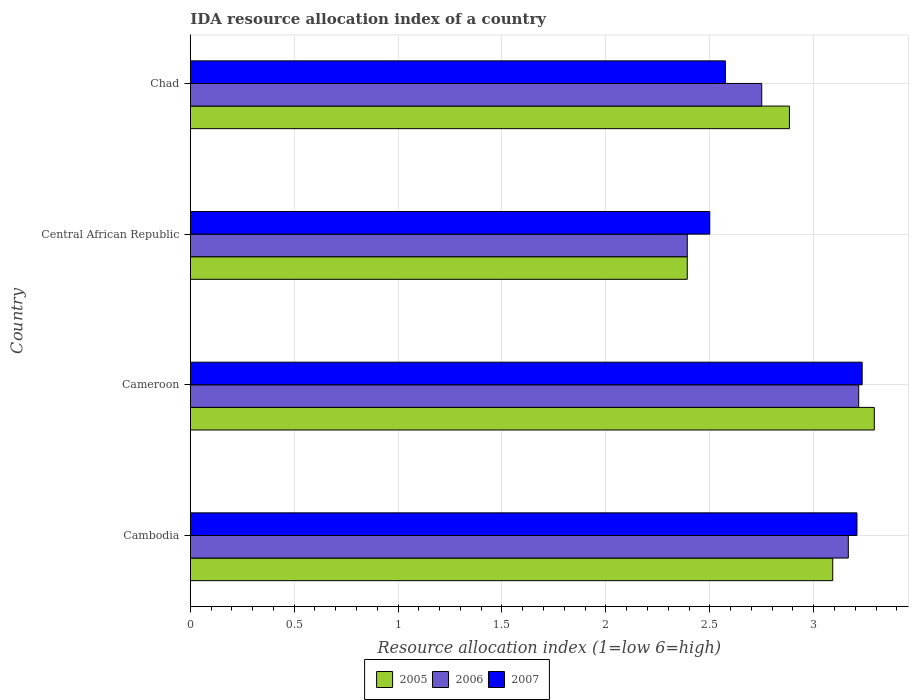How many groups of bars are there?
Provide a short and direct response. 4. Are the number of bars on each tick of the Y-axis equal?
Keep it short and to the point. Yes. How many bars are there on the 2nd tick from the bottom?
Ensure brevity in your answer.  3. What is the label of the 2nd group of bars from the top?
Provide a succinct answer. Central African Republic. What is the IDA resource allocation index in 2005 in Cameroon?
Ensure brevity in your answer.  3.29. Across all countries, what is the maximum IDA resource allocation index in 2006?
Keep it short and to the point. 3.22. Across all countries, what is the minimum IDA resource allocation index in 2005?
Make the answer very short. 2.39. In which country was the IDA resource allocation index in 2007 maximum?
Give a very brief answer. Cameroon. In which country was the IDA resource allocation index in 2005 minimum?
Provide a short and direct response. Central African Republic. What is the total IDA resource allocation index in 2006 in the graph?
Your response must be concise. 11.53. What is the difference between the IDA resource allocation index in 2006 in Cameroon and that in Chad?
Make the answer very short. 0.47. What is the difference between the IDA resource allocation index in 2007 in Cambodia and the IDA resource allocation index in 2006 in Chad?
Your answer should be compact. 0.46. What is the average IDA resource allocation index in 2006 per country?
Your answer should be compact. 2.88. What is the difference between the IDA resource allocation index in 2007 and IDA resource allocation index in 2006 in Central African Republic?
Ensure brevity in your answer.  0.11. What is the ratio of the IDA resource allocation index in 2005 in Cambodia to that in Central African Republic?
Your answer should be compact. 1.29. What is the difference between the highest and the second highest IDA resource allocation index in 2007?
Your answer should be very brief. 0.02. What is the difference between the highest and the lowest IDA resource allocation index in 2005?
Make the answer very short. 0.9. Is the sum of the IDA resource allocation index in 2006 in Cambodia and Cameroon greater than the maximum IDA resource allocation index in 2007 across all countries?
Ensure brevity in your answer.  Yes. Is it the case that in every country, the sum of the IDA resource allocation index in 2007 and IDA resource allocation index in 2006 is greater than the IDA resource allocation index in 2005?
Give a very brief answer. Yes. How many bars are there?
Give a very brief answer. 12. Are all the bars in the graph horizontal?
Your answer should be compact. Yes. Does the graph contain any zero values?
Provide a succinct answer. No. What is the title of the graph?
Provide a succinct answer. IDA resource allocation index of a country. What is the label or title of the X-axis?
Keep it short and to the point. Resource allocation index (1=low 6=high). What is the label or title of the Y-axis?
Your response must be concise. Country. What is the Resource allocation index (1=low 6=high) of 2005 in Cambodia?
Ensure brevity in your answer.  3.09. What is the Resource allocation index (1=low 6=high) in 2006 in Cambodia?
Offer a terse response. 3.17. What is the Resource allocation index (1=low 6=high) in 2007 in Cambodia?
Provide a short and direct response. 3.21. What is the Resource allocation index (1=low 6=high) in 2005 in Cameroon?
Give a very brief answer. 3.29. What is the Resource allocation index (1=low 6=high) in 2006 in Cameroon?
Provide a succinct answer. 3.22. What is the Resource allocation index (1=low 6=high) of 2007 in Cameroon?
Make the answer very short. 3.23. What is the Resource allocation index (1=low 6=high) in 2005 in Central African Republic?
Offer a terse response. 2.39. What is the Resource allocation index (1=low 6=high) in 2006 in Central African Republic?
Give a very brief answer. 2.39. What is the Resource allocation index (1=low 6=high) of 2005 in Chad?
Provide a short and direct response. 2.88. What is the Resource allocation index (1=low 6=high) of 2006 in Chad?
Offer a terse response. 2.75. What is the Resource allocation index (1=low 6=high) in 2007 in Chad?
Provide a short and direct response. 2.58. Across all countries, what is the maximum Resource allocation index (1=low 6=high) in 2005?
Provide a short and direct response. 3.29. Across all countries, what is the maximum Resource allocation index (1=low 6=high) of 2006?
Offer a very short reply. 3.22. Across all countries, what is the maximum Resource allocation index (1=low 6=high) of 2007?
Provide a short and direct response. 3.23. Across all countries, what is the minimum Resource allocation index (1=low 6=high) in 2005?
Provide a succinct answer. 2.39. Across all countries, what is the minimum Resource allocation index (1=low 6=high) in 2006?
Make the answer very short. 2.39. What is the total Resource allocation index (1=low 6=high) of 2005 in the graph?
Give a very brief answer. 11.66. What is the total Resource allocation index (1=low 6=high) of 2006 in the graph?
Offer a very short reply. 11.53. What is the total Resource allocation index (1=low 6=high) in 2007 in the graph?
Keep it short and to the point. 11.52. What is the difference between the Resource allocation index (1=low 6=high) of 2007 in Cambodia and that in Cameroon?
Make the answer very short. -0.03. What is the difference between the Resource allocation index (1=low 6=high) in 2005 in Cambodia and that in Central African Republic?
Offer a terse response. 0.7. What is the difference between the Resource allocation index (1=low 6=high) in 2006 in Cambodia and that in Central African Republic?
Provide a succinct answer. 0.78. What is the difference between the Resource allocation index (1=low 6=high) in 2007 in Cambodia and that in Central African Republic?
Keep it short and to the point. 0.71. What is the difference between the Resource allocation index (1=low 6=high) of 2005 in Cambodia and that in Chad?
Your response must be concise. 0.21. What is the difference between the Resource allocation index (1=low 6=high) in 2006 in Cambodia and that in Chad?
Keep it short and to the point. 0.42. What is the difference between the Resource allocation index (1=low 6=high) in 2007 in Cambodia and that in Chad?
Offer a terse response. 0.63. What is the difference between the Resource allocation index (1=low 6=high) of 2006 in Cameroon and that in Central African Republic?
Keep it short and to the point. 0.82. What is the difference between the Resource allocation index (1=low 6=high) in 2007 in Cameroon and that in Central African Republic?
Keep it short and to the point. 0.73. What is the difference between the Resource allocation index (1=low 6=high) of 2005 in Cameroon and that in Chad?
Give a very brief answer. 0.41. What is the difference between the Resource allocation index (1=low 6=high) of 2006 in Cameroon and that in Chad?
Your answer should be very brief. 0.47. What is the difference between the Resource allocation index (1=low 6=high) of 2007 in Cameroon and that in Chad?
Ensure brevity in your answer.  0.66. What is the difference between the Resource allocation index (1=low 6=high) in 2005 in Central African Republic and that in Chad?
Ensure brevity in your answer.  -0.49. What is the difference between the Resource allocation index (1=low 6=high) in 2006 in Central African Republic and that in Chad?
Ensure brevity in your answer.  -0.36. What is the difference between the Resource allocation index (1=low 6=high) of 2007 in Central African Republic and that in Chad?
Provide a short and direct response. -0.07. What is the difference between the Resource allocation index (1=low 6=high) in 2005 in Cambodia and the Resource allocation index (1=low 6=high) in 2006 in Cameroon?
Offer a terse response. -0.12. What is the difference between the Resource allocation index (1=low 6=high) in 2005 in Cambodia and the Resource allocation index (1=low 6=high) in 2007 in Cameroon?
Your answer should be very brief. -0.14. What is the difference between the Resource allocation index (1=low 6=high) in 2006 in Cambodia and the Resource allocation index (1=low 6=high) in 2007 in Cameroon?
Your response must be concise. -0.07. What is the difference between the Resource allocation index (1=low 6=high) of 2005 in Cambodia and the Resource allocation index (1=low 6=high) of 2007 in Central African Republic?
Your answer should be compact. 0.59. What is the difference between the Resource allocation index (1=low 6=high) of 2005 in Cambodia and the Resource allocation index (1=low 6=high) of 2006 in Chad?
Provide a short and direct response. 0.34. What is the difference between the Resource allocation index (1=low 6=high) in 2005 in Cambodia and the Resource allocation index (1=low 6=high) in 2007 in Chad?
Your response must be concise. 0.52. What is the difference between the Resource allocation index (1=low 6=high) of 2006 in Cambodia and the Resource allocation index (1=low 6=high) of 2007 in Chad?
Ensure brevity in your answer.  0.59. What is the difference between the Resource allocation index (1=low 6=high) of 2005 in Cameroon and the Resource allocation index (1=low 6=high) of 2006 in Central African Republic?
Provide a short and direct response. 0.9. What is the difference between the Resource allocation index (1=low 6=high) of 2005 in Cameroon and the Resource allocation index (1=low 6=high) of 2007 in Central African Republic?
Offer a very short reply. 0.79. What is the difference between the Resource allocation index (1=low 6=high) in 2006 in Cameroon and the Resource allocation index (1=low 6=high) in 2007 in Central African Republic?
Provide a succinct answer. 0.72. What is the difference between the Resource allocation index (1=low 6=high) in 2005 in Cameroon and the Resource allocation index (1=low 6=high) in 2006 in Chad?
Offer a very short reply. 0.54. What is the difference between the Resource allocation index (1=low 6=high) in 2005 in Cameroon and the Resource allocation index (1=low 6=high) in 2007 in Chad?
Provide a succinct answer. 0.72. What is the difference between the Resource allocation index (1=low 6=high) in 2006 in Cameroon and the Resource allocation index (1=low 6=high) in 2007 in Chad?
Offer a terse response. 0.64. What is the difference between the Resource allocation index (1=low 6=high) of 2005 in Central African Republic and the Resource allocation index (1=low 6=high) of 2006 in Chad?
Your answer should be compact. -0.36. What is the difference between the Resource allocation index (1=low 6=high) of 2005 in Central African Republic and the Resource allocation index (1=low 6=high) of 2007 in Chad?
Offer a terse response. -0.18. What is the difference between the Resource allocation index (1=low 6=high) in 2006 in Central African Republic and the Resource allocation index (1=low 6=high) in 2007 in Chad?
Keep it short and to the point. -0.18. What is the average Resource allocation index (1=low 6=high) in 2005 per country?
Provide a short and direct response. 2.91. What is the average Resource allocation index (1=low 6=high) of 2006 per country?
Provide a short and direct response. 2.88. What is the average Resource allocation index (1=low 6=high) of 2007 per country?
Your answer should be very brief. 2.88. What is the difference between the Resource allocation index (1=low 6=high) of 2005 and Resource allocation index (1=low 6=high) of 2006 in Cambodia?
Give a very brief answer. -0.07. What is the difference between the Resource allocation index (1=low 6=high) of 2005 and Resource allocation index (1=low 6=high) of 2007 in Cambodia?
Ensure brevity in your answer.  -0.12. What is the difference between the Resource allocation index (1=low 6=high) in 2006 and Resource allocation index (1=low 6=high) in 2007 in Cambodia?
Give a very brief answer. -0.04. What is the difference between the Resource allocation index (1=low 6=high) in 2005 and Resource allocation index (1=low 6=high) in 2006 in Cameroon?
Keep it short and to the point. 0.07. What is the difference between the Resource allocation index (1=low 6=high) in 2005 and Resource allocation index (1=low 6=high) in 2007 in Cameroon?
Your answer should be compact. 0.06. What is the difference between the Resource allocation index (1=low 6=high) of 2006 and Resource allocation index (1=low 6=high) of 2007 in Cameroon?
Your answer should be compact. -0.02. What is the difference between the Resource allocation index (1=low 6=high) in 2005 and Resource allocation index (1=low 6=high) in 2006 in Central African Republic?
Your answer should be very brief. 0. What is the difference between the Resource allocation index (1=low 6=high) of 2005 and Resource allocation index (1=low 6=high) of 2007 in Central African Republic?
Keep it short and to the point. -0.11. What is the difference between the Resource allocation index (1=low 6=high) of 2006 and Resource allocation index (1=low 6=high) of 2007 in Central African Republic?
Ensure brevity in your answer.  -0.11. What is the difference between the Resource allocation index (1=low 6=high) of 2005 and Resource allocation index (1=low 6=high) of 2006 in Chad?
Your answer should be compact. 0.13. What is the difference between the Resource allocation index (1=low 6=high) in 2005 and Resource allocation index (1=low 6=high) in 2007 in Chad?
Keep it short and to the point. 0.31. What is the difference between the Resource allocation index (1=low 6=high) in 2006 and Resource allocation index (1=low 6=high) in 2007 in Chad?
Offer a very short reply. 0.17. What is the ratio of the Resource allocation index (1=low 6=high) of 2005 in Cambodia to that in Cameroon?
Your response must be concise. 0.94. What is the ratio of the Resource allocation index (1=low 6=high) of 2006 in Cambodia to that in Cameroon?
Provide a succinct answer. 0.98. What is the ratio of the Resource allocation index (1=low 6=high) in 2007 in Cambodia to that in Cameroon?
Your answer should be compact. 0.99. What is the ratio of the Resource allocation index (1=low 6=high) in 2005 in Cambodia to that in Central African Republic?
Your answer should be compact. 1.29. What is the ratio of the Resource allocation index (1=low 6=high) in 2006 in Cambodia to that in Central African Republic?
Provide a succinct answer. 1.32. What is the ratio of the Resource allocation index (1=low 6=high) of 2007 in Cambodia to that in Central African Republic?
Give a very brief answer. 1.28. What is the ratio of the Resource allocation index (1=low 6=high) of 2005 in Cambodia to that in Chad?
Offer a terse response. 1.07. What is the ratio of the Resource allocation index (1=low 6=high) in 2006 in Cambodia to that in Chad?
Provide a succinct answer. 1.15. What is the ratio of the Resource allocation index (1=low 6=high) in 2007 in Cambodia to that in Chad?
Ensure brevity in your answer.  1.25. What is the ratio of the Resource allocation index (1=low 6=high) in 2005 in Cameroon to that in Central African Republic?
Offer a very short reply. 1.38. What is the ratio of the Resource allocation index (1=low 6=high) of 2006 in Cameroon to that in Central African Republic?
Your answer should be compact. 1.34. What is the ratio of the Resource allocation index (1=low 6=high) in 2007 in Cameroon to that in Central African Republic?
Ensure brevity in your answer.  1.29. What is the ratio of the Resource allocation index (1=low 6=high) of 2005 in Cameroon to that in Chad?
Provide a succinct answer. 1.14. What is the ratio of the Resource allocation index (1=low 6=high) in 2006 in Cameroon to that in Chad?
Keep it short and to the point. 1.17. What is the ratio of the Resource allocation index (1=low 6=high) of 2007 in Cameroon to that in Chad?
Provide a succinct answer. 1.26. What is the ratio of the Resource allocation index (1=low 6=high) of 2005 in Central African Republic to that in Chad?
Give a very brief answer. 0.83. What is the ratio of the Resource allocation index (1=low 6=high) of 2006 in Central African Republic to that in Chad?
Your answer should be very brief. 0.87. What is the ratio of the Resource allocation index (1=low 6=high) of 2007 in Central African Republic to that in Chad?
Offer a very short reply. 0.97. What is the difference between the highest and the second highest Resource allocation index (1=low 6=high) in 2005?
Give a very brief answer. 0.2. What is the difference between the highest and the second highest Resource allocation index (1=low 6=high) in 2006?
Keep it short and to the point. 0.05. What is the difference between the highest and the second highest Resource allocation index (1=low 6=high) in 2007?
Provide a succinct answer. 0.03. What is the difference between the highest and the lowest Resource allocation index (1=low 6=high) in 2005?
Your response must be concise. 0.9. What is the difference between the highest and the lowest Resource allocation index (1=low 6=high) of 2006?
Make the answer very short. 0.82. What is the difference between the highest and the lowest Resource allocation index (1=low 6=high) of 2007?
Provide a short and direct response. 0.73. 